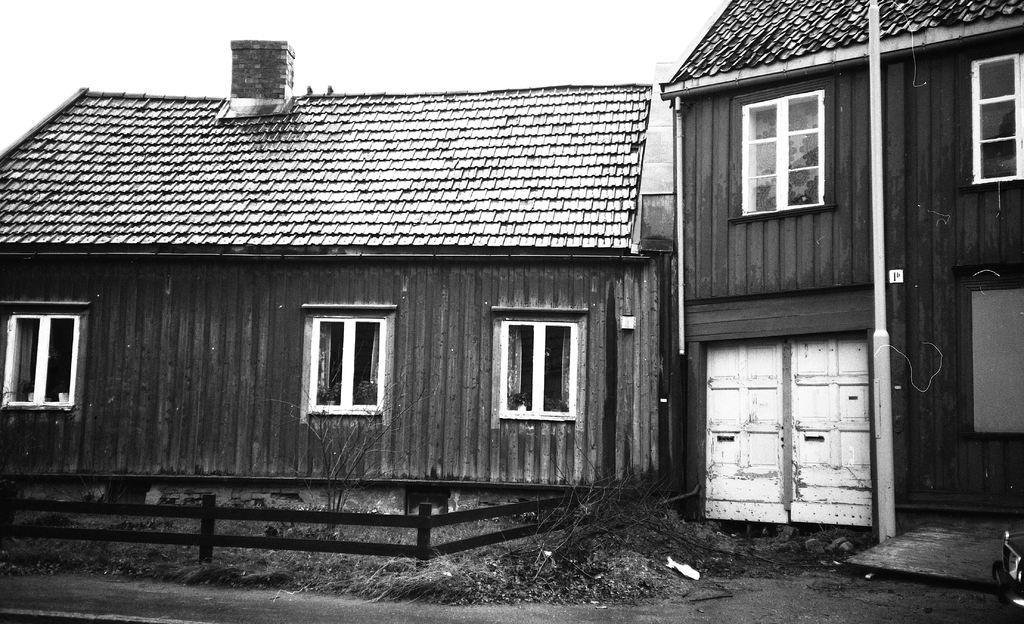Please provide a concise description of this image. In this picture I can see the buildings. On the right there is a pole which is placed near to the door and windows. At the top I can see the sky. At the bottom I can see the road, wooden fencing and grass. 